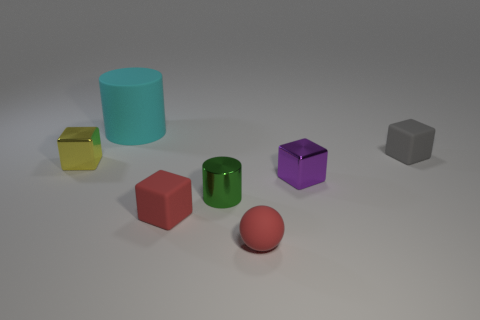Subtract all red cubes. How many cubes are left? 3 Add 1 big metallic cubes. How many objects exist? 8 Subtract all spheres. How many objects are left? 6 Subtract 1 cylinders. How many cylinders are left? 1 Subtract all cyan cylinders. How many cylinders are left? 1 Subtract all yellow matte blocks. Subtract all spheres. How many objects are left? 6 Add 7 red cubes. How many red cubes are left? 8 Add 2 tiny red matte balls. How many tiny red matte balls exist? 3 Subtract 0 brown cylinders. How many objects are left? 7 Subtract all cyan blocks. Subtract all brown spheres. How many blocks are left? 4 